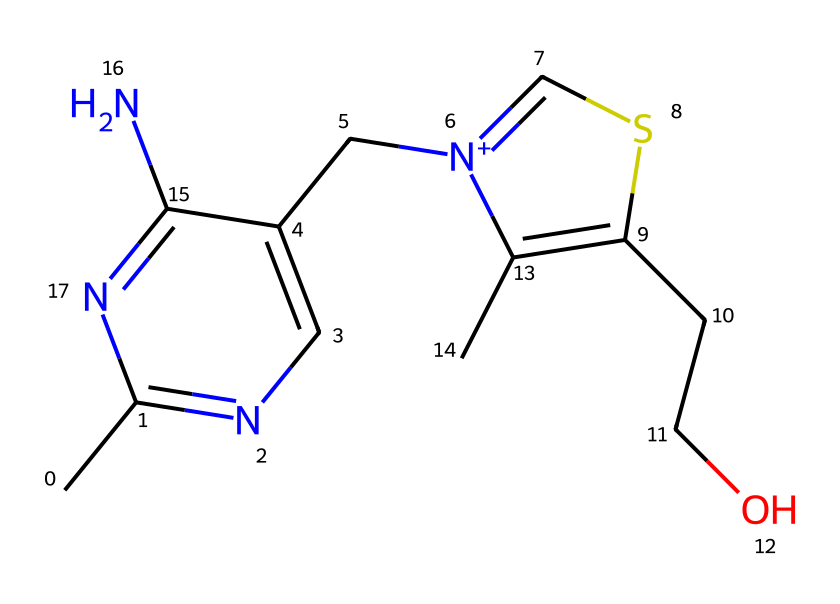What is the molecular formula of thiamine? The molecular formula can be derived by counting the number of each type of atom in the SMILES representation. The counts show that there are 12 carbon (C) atoms, 17 hydrogen (H) atoms, 4 nitrogen (N) atoms, and 2 sulfur (S) atoms. Thus, the formula is C12H17N4S.
Answer: C12H17N4S How many nitrogen atoms are present in the structure? By examining the SMILES representation, we can identify a total of four nitrogen atoms (N) scattered throughout the structure.
Answer: 4 Which functional groups are notable in thiamine? Upon analyzing the structure, we identify that thiamine contains an amine group (due to the nitrogen atoms) and a thiazole ring (from the sulfur and nitrogen in the ring structure). These functional groups are significant for its biological activity.
Answer: amine, thiazole Is thiamine a vitamin, and if so, what type? Thiamine is classified as a water-soluble vitamin because it dissolves in water and is essential for various bodily functions, including nervous system health.
Answer: water-soluble What role does sulfur play in thiamine? Sulfur is crucial for thiamine as it is part of the thiazole ring, impacting the molecular structure and function, particularly in energy metabolism and nervous system health.
Answer: thiazole Can thiamine be synthesized in the body? Humans cannot synthesize thiamine and must obtain it through their diet, making it an essential nutrient.
Answer: no 